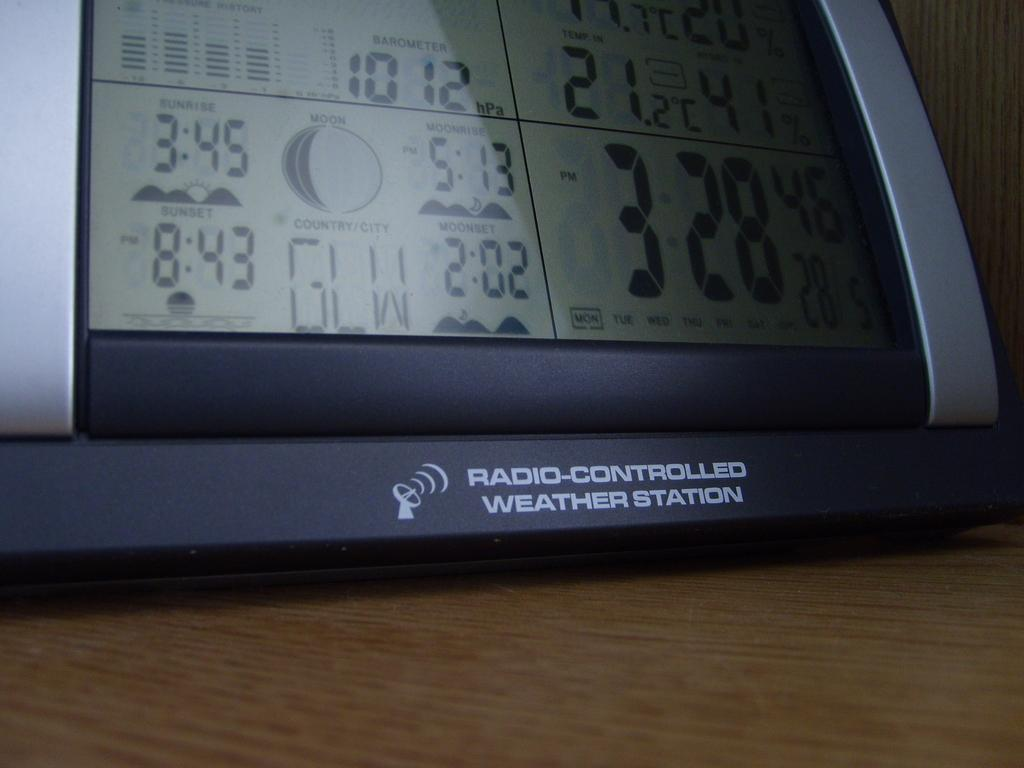Provide a one-sentence caption for the provided image. An electronic clock that shows that sunset is at 8:43. 